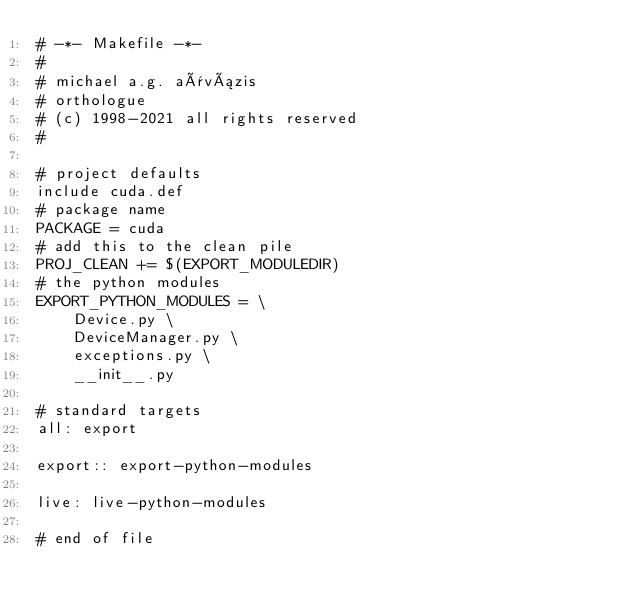Convert code to text. <code><loc_0><loc_0><loc_500><loc_500><_ObjectiveC_># -*- Makefile -*-
#
# michael a.g. aïvázis
# orthologue
# (c) 1998-2021 all rights reserved
#

# project defaults
include cuda.def
# package name
PACKAGE = cuda
# add this to the clean pile
PROJ_CLEAN += $(EXPORT_MODULEDIR)
# the python modules
EXPORT_PYTHON_MODULES = \
    Device.py \
    DeviceManager.py \
    exceptions.py \
    __init__.py

# standard targets
all: export

export:: export-python-modules

live: live-python-modules

# end of file
</code> 